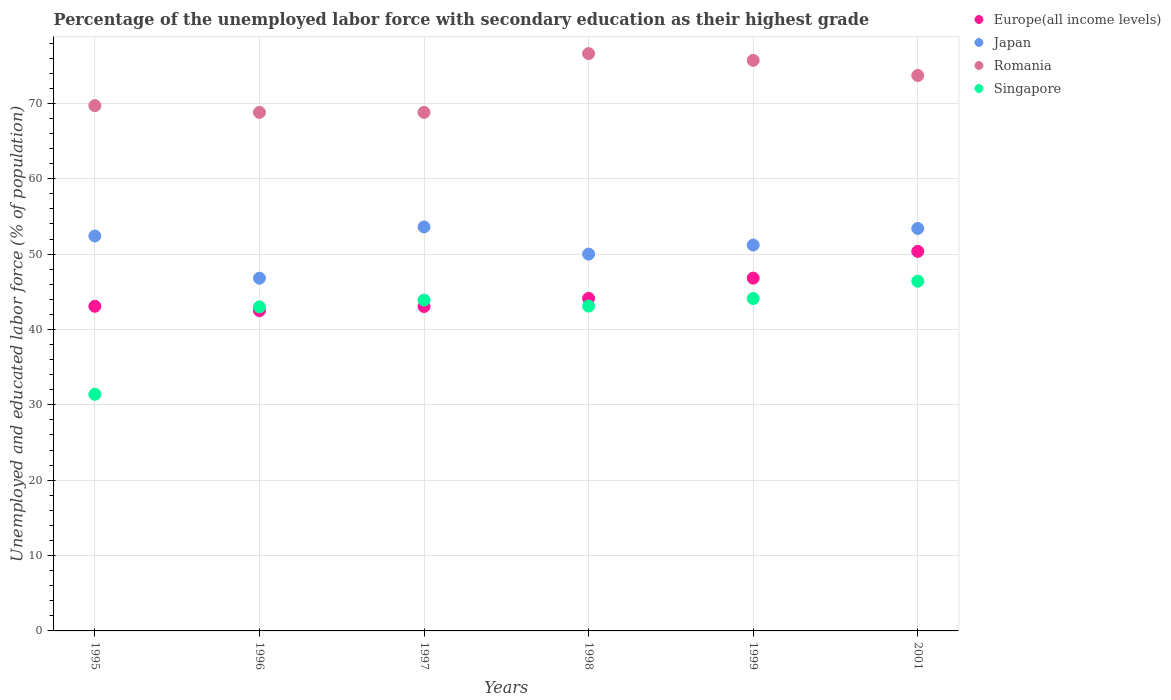What is the percentage of the unemployed labor force with secondary education in Japan in 2001?
Your answer should be very brief. 53.4. Across all years, what is the maximum percentage of the unemployed labor force with secondary education in Singapore?
Offer a terse response. 46.4. Across all years, what is the minimum percentage of the unemployed labor force with secondary education in Singapore?
Offer a very short reply. 31.4. In which year was the percentage of the unemployed labor force with secondary education in Europe(all income levels) minimum?
Your answer should be very brief. 1996. What is the total percentage of the unemployed labor force with secondary education in Romania in the graph?
Your answer should be very brief. 433.3. What is the difference between the percentage of the unemployed labor force with secondary education in Europe(all income levels) in 1995 and that in 1998?
Give a very brief answer. -1.05. What is the difference between the percentage of the unemployed labor force with secondary education in Europe(all income levels) in 1995 and the percentage of the unemployed labor force with secondary education in Romania in 1996?
Make the answer very short. -25.73. What is the average percentage of the unemployed labor force with secondary education in Romania per year?
Your answer should be very brief. 72.22. In the year 1997, what is the difference between the percentage of the unemployed labor force with secondary education in Japan and percentage of the unemployed labor force with secondary education in Romania?
Give a very brief answer. -15.2. What is the ratio of the percentage of the unemployed labor force with secondary education in Europe(all income levels) in 1996 to that in 2001?
Ensure brevity in your answer.  0.84. What is the difference between the highest and the second highest percentage of the unemployed labor force with secondary education in Europe(all income levels)?
Ensure brevity in your answer.  3.55. What is the difference between the highest and the lowest percentage of the unemployed labor force with secondary education in Europe(all income levels)?
Your answer should be very brief. 7.87. In how many years, is the percentage of the unemployed labor force with secondary education in Europe(all income levels) greater than the average percentage of the unemployed labor force with secondary education in Europe(all income levels) taken over all years?
Make the answer very short. 2. Is it the case that in every year, the sum of the percentage of the unemployed labor force with secondary education in Singapore and percentage of the unemployed labor force with secondary education in Europe(all income levels)  is greater than the sum of percentage of the unemployed labor force with secondary education in Japan and percentage of the unemployed labor force with secondary education in Romania?
Your answer should be compact. No. Is it the case that in every year, the sum of the percentage of the unemployed labor force with secondary education in Singapore and percentage of the unemployed labor force with secondary education in Romania  is greater than the percentage of the unemployed labor force with secondary education in Japan?
Offer a terse response. Yes. Is the percentage of the unemployed labor force with secondary education in Japan strictly greater than the percentage of the unemployed labor force with secondary education in Romania over the years?
Provide a succinct answer. No. How many years are there in the graph?
Offer a very short reply. 6. What is the difference between two consecutive major ticks on the Y-axis?
Ensure brevity in your answer.  10. How are the legend labels stacked?
Offer a very short reply. Vertical. What is the title of the graph?
Provide a succinct answer. Percentage of the unemployed labor force with secondary education as their highest grade. What is the label or title of the Y-axis?
Keep it short and to the point. Unemployed and educated labor force (% of population). What is the Unemployed and educated labor force (% of population) of Europe(all income levels) in 1995?
Make the answer very short. 43.07. What is the Unemployed and educated labor force (% of population) of Japan in 1995?
Make the answer very short. 52.4. What is the Unemployed and educated labor force (% of population) in Romania in 1995?
Ensure brevity in your answer.  69.7. What is the Unemployed and educated labor force (% of population) of Singapore in 1995?
Your answer should be very brief. 31.4. What is the Unemployed and educated labor force (% of population) of Europe(all income levels) in 1996?
Provide a short and direct response. 42.49. What is the Unemployed and educated labor force (% of population) of Japan in 1996?
Offer a very short reply. 46.8. What is the Unemployed and educated labor force (% of population) in Romania in 1996?
Give a very brief answer. 68.8. What is the Unemployed and educated labor force (% of population) in Europe(all income levels) in 1997?
Provide a short and direct response. 43.04. What is the Unemployed and educated labor force (% of population) in Japan in 1997?
Offer a terse response. 53.6. What is the Unemployed and educated labor force (% of population) of Romania in 1997?
Provide a short and direct response. 68.8. What is the Unemployed and educated labor force (% of population) of Singapore in 1997?
Ensure brevity in your answer.  43.9. What is the Unemployed and educated labor force (% of population) in Europe(all income levels) in 1998?
Your answer should be compact. 44.13. What is the Unemployed and educated labor force (% of population) of Japan in 1998?
Keep it short and to the point. 50. What is the Unemployed and educated labor force (% of population) of Romania in 1998?
Make the answer very short. 76.6. What is the Unemployed and educated labor force (% of population) of Singapore in 1998?
Provide a short and direct response. 43.1. What is the Unemployed and educated labor force (% of population) in Europe(all income levels) in 1999?
Give a very brief answer. 46.81. What is the Unemployed and educated labor force (% of population) in Japan in 1999?
Your response must be concise. 51.2. What is the Unemployed and educated labor force (% of population) in Romania in 1999?
Provide a succinct answer. 75.7. What is the Unemployed and educated labor force (% of population) of Singapore in 1999?
Your answer should be compact. 44.1. What is the Unemployed and educated labor force (% of population) of Europe(all income levels) in 2001?
Make the answer very short. 50.36. What is the Unemployed and educated labor force (% of population) of Japan in 2001?
Make the answer very short. 53.4. What is the Unemployed and educated labor force (% of population) in Romania in 2001?
Your response must be concise. 73.7. What is the Unemployed and educated labor force (% of population) in Singapore in 2001?
Ensure brevity in your answer.  46.4. Across all years, what is the maximum Unemployed and educated labor force (% of population) in Europe(all income levels)?
Your answer should be very brief. 50.36. Across all years, what is the maximum Unemployed and educated labor force (% of population) of Japan?
Your response must be concise. 53.6. Across all years, what is the maximum Unemployed and educated labor force (% of population) in Romania?
Your answer should be very brief. 76.6. Across all years, what is the maximum Unemployed and educated labor force (% of population) in Singapore?
Your answer should be compact. 46.4. Across all years, what is the minimum Unemployed and educated labor force (% of population) of Europe(all income levels)?
Make the answer very short. 42.49. Across all years, what is the minimum Unemployed and educated labor force (% of population) of Japan?
Your response must be concise. 46.8. Across all years, what is the minimum Unemployed and educated labor force (% of population) of Romania?
Your response must be concise. 68.8. Across all years, what is the minimum Unemployed and educated labor force (% of population) of Singapore?
Your answer should be very brief. 31.4. What is the total Unemployed and educated labor force (% of population) in Europe(all income levels) in the graph?
Ensure brevity in your answer.  269.91. What is the total Unemployed and educated labor force (% of population) in Japan in the graph?
Your response must be concise. 307.4. What is the total Unemployed and educated labor force (% of population) of Romania in the graph?
Your response must be concise. 433.3. What is the total Unemployed and educated labor force (% of population) in Singapore in the graph?
Offer a terse response. 251.9. What is the difference between the Unemployed and educated labor force (% of population) of Europe(all income levels) in 1995 and that in 1996?
Keep it short and to the point. 0.58. What is the difference between the Unemployed and educated labor force (% of population) in Singapore in 1995 and that in 1996?
Keep it short and to the point. -11.6. What is the difference between the Unemployed and educated labor force (% of population) of Europe(all income levels) in 1995 and that in 1997?
Provide a succinct answer. 0.03. What is the difference between the Unemployed and educated labor force (% of population) of Romania in 1995 and that in 1997?
Give a very brief answer. 0.9. What is the difference between the Unemployed and educated labor force (% of population) of Europe(all income levels) in 1995 and that in 1998?
Your answer should be compact. -1.05. What is the difference between the Unemployed and educated labor force (% of population) in Japan in 1995 and that in 1998?
Your answer should be very brief. 2.4. What is the difference between the Unemployed and educated labor force (% of population) in Romania in 1995 and that in 1998?
Your response must be concise. -6.9. What is the difference between the Unemployed and educated labor force (% of population) in Singapore in 1995 and that in 1998?
Offer a terse response. -11.7. What is the difference between the Unemployed and educated labor force (% of population) in Europe(all income levels) in 1995 and that in 1999?
Offer a terse response. -3.74. What is the difference between the Unemployed and educated labor force (% of population) in Japan in 1995 and that in 1999?
Your answer should be compact. 1.2. What is the difference between the Unemployed and educated labor force (% of population) in Romania in 1995 and that in 1999?
Ensure brevity in your answer.  -6. What is the difference between the Unemployed and educated labor force (% of population) of Europe(all income levels) in 1995 and that in 2001?
Offer a terse response. -7.29. What is the difference between the Unemployed and educated labor force (% of population) of Japan in 1995 and that in 2001?
Ensure brevity in your answer.  -1. What is the difference between the Unemployed and educated labor force (% of population) of Europe(all income levels) in 1996 and that in 1997?
Provide a succinct answer. -0.55. What is the difference between the Unemployed and educated labor force (% of population) of Japan in 1996 and that in 1997?
Ensure brevity in your answer.  -6.8. What is the difference between the Unemployed and educated labor force (% of population) in Romania in 1996 and that in 1997?
Give a very brief answer. 0. What is the difference between the Unemployed and educated labor force (% of population) in Europe(all income levels) in 1996 and that in 1998?
Your answer should be very brief. -1.64. What is the difference between the Unemployed and educated labor force (% of population) of Romania in 1996 and that in 1998?
Offer a terse response. -7.8. What is the difference between the Unemployed and educated labor force (% of population) in Europe(all income levels) in 1996 and that in 1999?
Provide a succinct answer. -4.32. What is the difference between the Unemployed and educated labor force (% of population) in Romania in 1996 and that in 1999?
Your response must be concise. -6.9. What is the difference between the Unemployed and educated labor force (% of population) in Singapore in 1996 and that in 1999?
Your response must be concise. -1.1. What is the difference between the Unemployed and educated labor force (% of population) in Europe(all income levels) in 1996 and that in 2001?
Make the answer very short. -7.87. What is the difference between the Unemployed and educated labor force (% of population) in Europe(all income levels) in 1997 and that in 1998?
Ensure brevity in your answer.  -1.08. What is the difference between the Unemployed and educated labor force (% of population) of Romania in 1997 and that in 1998?
Give a very brief answer. -7.8. What is the difference between the Unemployed and educated labor force (% of population) of Europe(all income levels) in 1997 and that in 1999?
Offer a very short reply. -3.76. What is the difference between the Unemployed and educated labor force (% of population) in Europe(all income levels) in 1997 and that in 2001?
Your response must be concise. -7.32. What is the difference between the Unemployed and educated labor force (% of population) of Singapore in 1997 and that in 2001?
Keep it short and to the point. -2.5. What is the difference between the Unemployed and educated labor force (% of population) in Europe(all income levels) in 1998 and that in 1999?
Make the answer very short. -2.68. What is the difference between the Unemployed and educated labor force (% of population) of Europe(all income levels) in 1998 and that in 2001?
Your answer should be compact. -6.23. What is the difference between the Unemployed and educated labor force (% of population) in Romania in 1998 and that in 2001?
Your answer should be very brief. 2.9. What is the difference between the Unemployed and educated labor force (% of population) of Europe(all income levels) in 1999 and that in 2001?
Your response must be concise. -3.55. What is the difference between the Unemployed and educated labor force (% of population) in Japan in 1999 and that in 2001?
Your answer should be very brief. -2.2. What is the difference between the Unemployed and educated labor force (% of population) of Romania in 1999 and that in 2001?
Offer a terse response. 2. What is the difference between the Unemployed and educated labor force (% of population) in Europe(all income levels) in 1995 and the Unemployed and educated labor force (% of population) in Japan in 1996?
Ensure brevity in your answer.  -3.73. What is the difference between the Unemployed and educated labor force (% of population) in Europe(all income levels) in 1995 and the Unemployed and educated labor force (% of population) in Romania in 1996?
Your response must be concise. -25.73. What is the difference between the Unemployed and educated labor force (% of population) in Europe(all income levels) in 1995 and the Unemployed and educated labor force (% of population) in Singapore in 1996?
Offer a terse response. 0.07. What is the difference between the Unemployed and educated labor force (% of population) in Japan in 1995 and the Unemployed and educated labor force (% of population) in Romania in 1996?
Your response must be concise. -16.4. What is the difference between the Unemployed and educated labor force (% of population) of Japan in 1995 and the Unemployed and educated labor force (% of population) of Singapore in 1996?
Your answer should be compact. 9.4. What is the difference between the Unemployed and educated labor force (% of population) in Romania in 1995 and the Unemployed and educated labor force (% of population) in Singapore in 1996?
Provide a succinct answer. 26.7. What is the difference between the Unemployed and educated labor force (% of population) in Europe(all income levels) in 1995 and the Unemployed and educated labor force (% of population) in Japan in 1997?
Keep it short and to the point. -10.53. What is the difference between the Unemployed and educated labor force (% of population) in Europe(all income levels) in 1995 and the Unemployed and educated labor force (% of population) in Romania in 1997?
Offer a terse response. -25.73. What is the difference between the Unemployed and educated labor force (% of population) of Europe(all income levels) in 1995 and the Unemployed and educated labor force (% of population) of Singapore in 1997?
Your response must be concise. -0.83. What is the difference between the Unemployed and educated labor force (% of population) of Japan in 1995 and the Unemployed and educated labor force (% of population) of Romania in 1997?
Ensure brevity in your answer.  -16.4. What is the difference between the Unemployed and educated labor force (% of population) of Japan in 1995 and the Unemployed and educated labor force (% of population) of Singapore in 1997?
Offer a very short reply. 8.5. What is the difference between the Unemployed and educated labor force (% of population) in Romania in 1995 and the Unemployed and educated labor force (% of population) in Singapore in 1997?
Keep it short and to the point. 25.8. What is the difference between the Unemployed and educated labor force (% of population) of Europe(all income levels) in 1995 and the Unemployed and educated labor force (% of population) of Japan in 1998?
Make the answer very short. -6.93. What is the difference between the Unemployed and educated labor force (% of population) in Europe(all income levels) in 1995 and the Unemployed and educated labor force (% of population) in Romania in 1998?
Provide a short and direct response. -33.53. What is the difference between the Unemployed and educated labor force (% of population) of Europe(all income levels) in 1995 and the Unemployed and educated labor force (% of population) of Singapore in 1998?
Your response must be concise. -0.03. What is the difference between the Unemployed and educated labor force (% of population) in Japan in 1995 and the Unemployed and educated labor force (% of population) in Romania in 1998?
Ensure brevity in your answer.  -24.2. What is the difference between the Unemployed and educated labor force (% of population) of Romania in 1995 and the Unemployed and educated labor force (% of population) of Singapore in 1998?
Offer a terse response. 26.6. What is the difference between the Unemployed and educated labor force (% of population) in Europe(all income levels) in 1995 and the Unemployed and educated labor force (% of population) in Japan in 1999?
Your answer should be very brief. -8.13. What is the difference between the Unemployed and educated labor force (% of population) in Europe(all income levels) in 1995 and the Unemployed and educated labor force (% of population) in Romania in 1999?
Keep it short and to the point. -32.63. What is the difference between the Unemployed and educated labor force (% of population) in Europe(all income levels) in 1995 and the Unemployed and educated labor force (% of population) in Singapore in 1999?
Offer a terse response. -1.03. What is the difference between the Unemployed and educated labor force (% of population) of Japan in 1995 and the Unemployed and educated labor force (% of population) of Romania in 1999?
Give a very brief answer. -23.3. What is the difference between the Unemployed and educated labor force (% of population) in Japan in 1995 and the Unemployed and educated labor force (% of population) in Singapore in 1999?
Provide a succinct answer. 8.3. What is the difference between the Unemployed and educated labor force (% of population) in Romania in 1995 and the Unemployed and educated labor force (% of population) in Singapore in 1999?
Offer a terse response. 25.6. What is the difference between the Unemployed and educated labor force (% of population) of Europe(all income levels) in 1995 and the Unemployed and educated labor force (% of population) of Japan in 2001?
Offer a terse response. -10.33. What is the difference between the Unemployed and educated labor force (% of population) in Europe(all income levels) in 1995 and the Unemployed and educated labor force (% of population) in Romania in 2001?
Your answer should be compact. -30.63. What is the difference between the Unemployed and educated labor force (% of population) of Europe(all income levels) in 1995 and the Unemployed and educated labor force (% of population) of Singapore in 2001?
Keep it short and to the point. -3.33. What is the difference between the Unemployed and educated labor force (% of population) of Japan in 1995 and the Unemployed and educated labor force (% of population) of Romania in 2001?
Provide a short and direct response. -21.3. What is the difference between the Unemployed and educated labor force (% of population) in Japan in 1995 and the Unemployed and educated labor force (% of population) in Singapore in 2001?
Provide a short and direct response. 6. What is the difference between the Unemployed and educated labor force (% of population) in Romania in 1995 and the Unemployed and educated labor force (% of population) in Singapore in 2001?
Your response must be concise. 23.3. What is the difference between the Unemployed and educated labor force (% of population) of Europe(all income levels) in 1996 and the Unemployed and educated labor force (% of population) of Japan in 1997?
Your answer should be compact. -11.11. What is the difference between the Unemployed and educated labor force (% of population) of Europe(all income levels) in 1996 and the Unemployed and educated labor force (% of population) of Romania in 1997?
Your response must be concise. -26.31. What is the difference between the Unemployed and educated labor force (% of population) of Europe(all income levels) in 1996 and the Unemployed and educated labor force (% of population) of Singapore in 1997?
Make the answer very short. -1.41. What is the difference between the Unemployed and educated labor force (% of population) in Japan in 1996 and the Unemployed and educated labor force (% of population) in Romania in 1997?
Your response must be concise. -22. What is the difference between the Unemployed and educated labor force (% of population) in Romania in 1996 and the Unemployed and educated labor force (% of population) in Singapore in 1997?
Your answer should be compact. 24.9. What is the difference between the Unemployed and educated labor force (% of population) of Europe(all income levels) in 1996 and the Unemployed and educated labor force (% of population) of Japan in 1998?
Your answer should be very brief. -7.51. What is the difference between the Unemployed and educated labor force (% of population) of Europe(all income levels) in 1996 and the Unemployed and educated labor force (% of population) of Romania in 1998?
Keep it short and to the point. -34.11. What is the difference between the Unemployed and educated labor force (% of population) in Europe(all income levels) in 1996 and the Unemployed and educated labor force (% of population) in Singapore in 1998?
Make the answer very short. -0.61. What is the difference between the Unemployed and educated labor force (% of population) of Japan in 1996 and the Unemployed and educated labor force (% of population) of Romania in 1998?
Your answer should be very brief. -29.8. What is the difference between the Unemployed and educated labor force (% of population) of Japan in 1996 and the Unemployed and educated labor force (% of population) of Singapore in 1998?
Keep it short and to the point. 3.7. What is the difference between the Unemployed and educated labor force (% of population) in Romania in 1996 and the Unemployed and educated labor force (% of population) in Singapore in 1998?
Give a very brief answer. 25.7. What is the difference between the Unemployed and educated labor force (% of population) of Europe(all income levels) in 1996 and the Unemployed and educated labor force (% of population) of Japan in 1999?
Provide a succinct answer. -8.71. What is the difference between the Unemployed and educated labor force (% of population) of Europe(all income levels) in 1996 and the Unemployed and educated labor force (% of population) of Romania in 1999?
Your response must be concise. -33.21. What is the difference between the Unemployed and educated labor force (% of population) of Europe(all income levels) in 1996 and the Unemployed and educated labor force (% of population) of Singapore in 1999?
Your response must be concise. -1.61. What is the difference between the Unemployed and educated labor force (% of population) in Japan in 1996 and the Unemployed and educated labor force (% of population) in Romania in 1999?
Your answer should be very brief. -28.9. What is the difference between the Unemployed and educated labor force (% of population) of Japan in 1996 and the Unemployed and educated labor force (% of population) of Singapore in 1999?
Provide a short and direct response. 2.7. What is the difference between the Unemployed and educated labor force (% of population) of Romania in 1996 and the Unemployed and educated labor force (% of population) of Singapore in 1999?
Offer a very short reply. 24.7. What is the difference between the Unemployed and educated labor force (% of population) in Europe(all income levels) in 1996 and the Unemployed and educated labor force (% of population) in Japan in 2001?
Your answer should be very brief. -10.91. What is the difference between the Unemployed and educated labor force (% of population) of Europe(all income levels) in 1996 and the Unemployed and educated labor force (% of population) of Romania in 2001?
Your answer should be very brief. -31.21. What is the difference between the Unemployed and educated labor force (% of population) in Europe(all income levels) in 1996 and the Unemployed and educated labor force (% of population) in Singapore in 2001?
Offer a very short reply. -3.91. What is the difference between the Unemployed and educated labor force (% of population) of Japan in 1996 and the Unemployed and educated labor force (% of population) of Romania in 2001?
Your response must be concise. -26.9. What is the difference between the Unemployed and educated labor force (% of population) in Japan in 1996 and the Unemployed and educated labor force (% of population) in Singapore in 2001?
Offer a very short reply. 0.4. What is the difference between the Unemployed and educated labor force (% of population) of Romania in 1996 and the Unemployed and educated labor force (% of population) of Singapore in 2001?
Keep it short and to the point. 22.4. What is the difference between the Unemployed and educated labor force (% of population) in Europe(all income levels) in 1997 and the Unemployed and educated labor force (% of population) in Japan in 1998?
Your response must be concise. -6.96. What is the difference between the Unemployed and educated labor force (% of population) of Europe(all income levels) in 1997 and the Unemployed and educated labor force (% of population) of Romania in 1998?
Your response must be concise. -33.56. What is the difference between the Unemployed and educated labor force (% of population) in Europe(all income levels) in 1997 and the Unemployed and educated labor force (% of population) in Singapore in 1998?
Keep it short and to the point. -0.06. What is the difference between the Unemployed and educated labor force (% of population) in Japan in 1997 and the Unemployed and educated labor force (% of population) in Singapore in 1998?
Offer a terse response. 10.5. What is the difference between the Unemployed and educated labor force (% of population) in Romania in 1997 and the Unemployed and educated labor force (% of population) in Singapore in 1998?
Offer a terse response. 25.7. What is the difference between the Unemployed and educated labor force (% of population) of Europe(all income levels) in 1997 and the Unemployed and educated labor force (% of population) of Japan in 1999?
Ensure brevity in your answer.  -8.16. What is the difference between the Unemployed and educated labor force (% of population) of Europe(all income levels) in 1997 and the Unemployed and educated labor force (% of population) of Romania in 1999?
Offer a very short reply. -32.66. What is the difference between the Unemployed and educated labor force (% of population) of Europe(all income levels) in 1997 and the Unemployed and educated labor force (% of population) of Singapore in 1999?
Provide a short and direct response. -1.06. What is the difference between the Unemployed and educated labor force (% of population) of Japan in 1997 and the Unemployed and educated labor force (% of population) of Romania in 1999?
Offer a very short reply. -22.1. What is the difference between the Unemployed and educated labor force (% of population) in Japan in 1997 and the Unemployed and educated labor force (% of population) in Singapore in 1999?
Your response must be concise. 9.5. What is the difference between the Unemployed and educated labor force (% of population) of Romania in 1997 and the Unemployed and educated labor force (% of population) of Singapore in 1999?
Your answer should be very brief. 24.7. What is the difference between the Unemployed and educated labor force (% of population) in Europe(all income levels) in 1997 and the Unemployed and educated labor force (% of population) in Japan in 2001?
Your answer should be compact. -10.36. What is the difference between the Unemployed and educated labor force (% of population) in Europe(all income levels) in 1997 and the Unemployed and educated labor force (% of population) in Romania in 2001?
Provide a short and direct response. -30.66. What is the difference between the Unemployed and educated labor force (% of population) in Europe(all income levels) in 1997 and the Unemployed and educated labor force (% of population) in Singapore in 2001?
Your answer should be compact. -3.36. What is the difference between the Unemployed and educated labor force (% of population) in Japan in 1997 and the Unemployed and educated labor force (% of population) in Romania in 2001?
Your response must be concise. -20.1. What is the difference between the Unemployed and educated labor force (% of population) of Romania in 1997 and the Unemployed and educated labor force (% of population) of Singapore in 2001?
Provide a succinct answer. 22.4. What is the difference between the Unemployed and educated labor force (% of population) in Europe(all income levels) in 1998 and the Unemployed and educated labor force (% of population) in Japan in 1999?
Offer a terse response. -7.07. What is the difference between the Unemployed and educated labor force (% of population) of Europe(all income levels) in 1998 and the Unemployed and educated labor force (% of population) of Romania in 1999?
Give a very brief answer. -31.57. What is the difference between the Unemployed and educated labor force (% of population) of Europe(all income levels) in 1998 and the Unemployed and educated labor force (% of population) of Singapore in 1999?
Your answer should be very brief. 0.03. What is the difference between the Unemployed and educated labor force (% of population) in Japan in 1998 and the Unemployed and educated labor force (% of population) in Romania in 1999?
Your answer should be very brief. -25.7. What is the difference between the Unemployed and educated labor force (% of population) of Japan in 1998 and the Unemployed and educated labor force (% of population) of Singapore in 1999?
Provide a succinct answer. 5.9. What is the difference between the Unemployed and educated labor force (% of population) of Romania in 1998 and the Unemployed and educated labor force (% of population) of Singapore in 1999?
Provide a succinct answer. 32.5. What is the difference between the Unemployed and educated labor force (% of population) of Europe(all income levels) in 1998 and the Unemployed and educated labor force (% of population) of Japan in 2001?
Provide a succinct answer. -9.27. What is the difference between the Unemployed and educated labor force (% of population) in Europe(all income levels) in 1998 and the Unemployed and educated labor force (% of population) in Romania in 2001?
Keep it short and to the point. -29.57. What is the difference between the Unemployed and educated labor force (% of population) of Europe(all income levels) in 1998 and the Unemployed and educated labor force (% of population) of Singapore in 2001?
Your answer should be very brief. -2.27. What is the difference between the Unemployed and educated labor force (% of population) in Japan in 1998 and the Unemployed and educated labor force (% of population) in Romania in 2001?
Give a very brief answer. -23.7. What is the difference between the Unemployed and educated labor force (% of population) of Romania in 1998 and the Unemployed and educated labor force (% of population) of Singapore in 2001?
Your response must be concise. 30.2. What is the difference between the Unemployed and educated labor force (% of population) in Europe(all income levels) in 1999 and the Unemployed and educated labor force (% of population) in Japan in 2001?
Your response must be concise. -6.59. What is the difference between the Unemployed and educated labor force (% of population) in Europe(all income levels) in 1999 and the Unemployed and educated labor force (% of population) in Romania in 2001?
Provide a short and direct response. -26.89. What is the difference between the Unemployed and educated labor force (% of population) in Europe(all income levels) in 1999 and the Unemployed and educated labor force (% of population) in Singapore in 2001?
Offer a very short reply. 0.41. What is the difference between the Unemployed and educated labor force (% of population) in Japan in 1999 and the Unemployed and educated labor force (% of population) in Romania in 2001?
Offer a terse response. -22.5. What is the difference between the Unemployed and educated labor force (% of population) of Romania in 1999 and the Unemployed and educated labor force (% of population) of Singapore in 2001?
Provide a succinct answer. 29.3. What is the average Unemployed and educated labor force (% of population) of Europe(all income levels) per year?
Make the answer very short. 44.98. What is the average Unemployed and educated labor force (% of population) in Japan per year?
Your response must be concise. 51.23. What is the average Unemployed and educated labor force (% of population) of Romania per year?
Offer a terse response. 72.22. What is the average Unemployed and educated labor force (% of population) of Singapore per year?
Your answer should be compact. 41.98. In the year 1995, what is the difference between the Unemployed and educated labor force (% of population) in Europe(all income levels) and Unemployed and educated labor force (% of population) in Japan?
Your answer should be compact. -9.33. In the year 1995, what is the difference between the Unemployed and educated labor force (% of population) of Europe(all income levels) and Unemployed and educated labor force (% of population) of Romania?
Provide a short and direct response. -26.63. In the year 1995, what is the difference between the Unemployed and educated labor force (% of population) of Europe(all income levels) and Unemployed and educated labor force (% of population) of Singapore?
Keep it short and to the point. 11.67. In the year 1995, what is the difference between the Unemployed and educated labor force (% of population) of Japan and Unemployed and educated labor force (% of population) of Romania?
Make the answer very short. -17.3. In the year 1995, what is the difference between the Unemployed and educated labor force (% of population) in Japan and Unemployed and educated labor force (% of population) in Singapore?
Keep it short and to the point. 21. In the year 1995, what is the difference between the Unemployed and educated labor force (% of population) of Romania and Unemployed and educated labor force (% of population) of Singapore?
Your answer should be very brief. 38.3. In the year 1996, what is the difference between the Unemployed and educated labor force (% of population) in Europe(all income levels) and Unemployed and educated labor force (% of population) in Japan?
Make the answer very short. -4.31. In the year 1996, what is the difference between the Unemployed and educated labor force (% of population) of Europe(all income levels) and Unemployed and educated labor force (% of population) of Romania?
Keep it short and to the point. -26.31. In the year 1996, what is the difference between the Unemployed and educated labor force (% of population) in Europe(all income levels) and Unemployed and educated labor force (% of population) in Singapore?
Provide a succinct answer. -0.51. In the year 1996, what is the difference between the Unemployed and educated labor force (% of population) in Japan and Unemployed and educated labor force (% of population) in Romania?
Offer a terse response. -22. In the year 1996, what is the difference between the Unemployed and educated labor force (% of population) of Japan and Unemployed and educated labor force (% of population) of Singapore?
Offer a very short reply. 3.8. In the year 1996, what is the difference between the Unemployed and educated labor force (% of population) of Romania and Unemployed and educated labor force (% of population) of Singapore?
Your answer should be compact. 25.8. In the year 1997, what is the difference between the Unemployed and educated labor force (% of population) in Europe(all income levels) and Unemployed and educated labor force (% of population) in Japan?
Give a very brief answer. -10.56. In the year 1997, what is the difference between the Unemployed and educated labor force (% of population) of Europe(all income levels) and Unemployed and educated labor force (% of population) of Romania?
Make the answer very short. -25.76. In the year 1997, what is the difference between the Unemployed and educated labor force (% of population) of Europe(all income levels) and Unemployed and educated labor force (% of population) of Singapore?
Provide a succinct answer. -0.86. In the year 1997, what is the difference between the Unemployed and educated labor force (% of population) of Japan and Unemployed and educated labor force (% of population) of Romania?
Offer a terse response. -15.2. In the year 1997, what is the difference between the Unemployed and educated labor force (% of population) of Romania and Unemployed and educated labor force (% of population) of Singapore?
Ensure brevity in your answer.  24.9. In the year 1998, what is the difference between the Unemployed and educated labor force (% of population) of Europe(all income levels) and Unemployed and educated labor force (% of population) of Japan?
Offer a very short reply. -5.87. In the year 1998, what is the difference between the Unemployed and educated labor force (% of population) in Europe(all income levels) and Unemployed and educated labor force (% of population) in Romania?
Your answer should be compact. -32.47. In the year 1998, what is the difference between the Unemployed and educated labor force (% of population) in Europe(all income levels) and Unemployed and educated labor force (% of population) in Singapore?
Provide a short and direct response. 1.03. In the year 1998, what is the difference between the Unemployed and educated labor force (% of population) of Japan and Unemployed and educated labor force (% of population) of Romania?
Your answer should be very brief. -26.6. In the year 1998, what is the difference between the Unemployed and educated labor force (% of population) of Japan and Unemployed and educated labor force (% of population) of Singapore?
Keep it short and to the point. 6.9. In the year 1998, what is the difference between the Unemployed and educated labor force (% of population) of Romania and Unemployed and educated labor force (% of population) of Singapore?
Make the answer very short. 33.5. In the year 1999, what is the difference between the Unemployed and educated labor force (% of population) of Europe(all income levels) and Unemployed and educated labor force (% of population) of Japan?
Your response must be concise. -4.39. In the year 1999, what is the difference between the Unemployed and educated labor force (% of population) of Europe(all income levels) and Unemployed and educated labor force (% of population) of Romania?
Ensure brevity in your answer.  -28.89. In the year 1999, what is the difference between the Unemployed and educated labor force (% of population) in Europe(all income levels) and Unemployed and educated labor force (% of population) in Singapore?
Keep it short and to the point. 2.71. In the year 1999, what is the difference between the Unemployed and educated labor force (% of population) in Japan and Unemployed and educated labor force (% of population) in Romania?
Provide a succinct answer. -24.5. In the year 1999, what is the difference between the Unemployed and educated labor force (% of population) in Romania and Unemployed and educated labor force (% of population) in Singapore?
Your response must be concise. 31.6. In the year 2001, what is the difference between the Unemployed and educated labor force (% of population) of Europe(all income levels) and Unemployed and educated labor force (% of population) of Japan?
Your answer should be very brief. -3.04. In the year 2001, what is the difference between the Unemployed and educated labor force (% of population) in Europe(all income levels) and Unemployed and educated labor force (% of population) in Romania?
Give a very brief answer. -23.34. In the year 2001, what is the difference between the Unemployed and educated labor force (% of population) in Europe(all income levels) and Unemployed and educated labor force (% of population) in Singapore?
Your response must be concise. 3.96. In the year 2001, what is the difference between the Unemployed and educated labor force (% of population) in Japan and Unemployed and educated labor force (% of population) in Romania?
Offer a very short reply. -20.3. In the year 2001, what is the difference between the Unemployed and educated labor force (% of population) in Romania and Unemployed and educated labor force (% of population) in Singapore?
Provide a short and direct response. 27.3. What is the ratio of the Unemployed and educated labor force (% of population) in Europe(all income levels) in 1995 to that in 1996?
Provide a short and direct response. 1.01. What is the ratio of the Unemployed and educated labor force (% of population) of Japan in 1995 to that in 1996?
Give a very brief answer. 1.12. What is the ratio of the Unemployed and educated labor force (% of population) of Romania in 1995 to that in 1996?
Offer a very short reply. 1.01. What is the ratio of the Unemployed and educated labor force (% of population) in Singapore in 1995 to that in 1996?
Your answer should be compact. 0.73. What is the ratio of the Unemployed and educated labor force (% of population) in Japan in 1995 to that in 1997?
Ensure brevity in your answer.  0.98. What is the ratio of the Unemployed and educated labor force (% of population) of Romania in 1995 to that in 1997?
Your answer should be compact. 1.01. What is the ratio of the Unemployed and educated labor force (% of population) of Singapore in 1995 to that in 1997?
Provide a short and direct response. 0.72. What is the ratio of the Unemployed and educated labor force (% of population) of Europe(all income levels) in 1995 to that in 1998?
Your answer should be very brief. 0.98. What is the ratio of the Unemployed and educated labor force (% of population) in Japan in 1995 to that in 1998?
Offer a terse response. 1.05. What is the ratio of the Unemployed and educated labor force (% of population) in Romania in 1995 to that in 1998?
Keep it short and to the point. 0.91. What is the ratio of the Unemployed and educated labor force (% of population) of Singapore in 1995 to that in 1998?
Offer a terse response. 0.73. What is the ratio of the Unemployed and educated labor force (% of population) in Europe(all income levels) in 1995 to that in 1999?
Offer a very short reply. 0.92. What is the ratio of the Unemployed and educated labor force (% of population) in Japan in 1995 to that in 1999?
Your answer should be compact. 1.02. What is the ratio of the Unemployed and educated labor force (% of population) in Romania in 1995 to that in 1999?
Your answer should be very brief. 0.92. What is the ratio of the Unemployed and educated labor force (% of population) in Singapore in 1995 to that in 1999?
Ensure brevity in your answer.  0.71. What is the ratio of the Unemployed and educated labor force (% of population) of Europe(all income levels) in 1995 to that in 2001?
Give a very brief answer. 0.86. What is the ratio of the Unemployed and educated labor force (% of population) in Japan in 1995 to that in 2001?
Make the answer very short. 0.98. What is the ratio of the Unemployed and educated labor force (% of population) in Romania in 1995 to that in 2001?
Your answer should be compact. 0.95. What is the ratio of the Unemployed and educated labor force (% of population) of Singapore in 1995 to that in 2001?
Ensure brevity in your answer.  0.68. What is the ratio of the Unemployed and educated labor force (% of population) of Europe(all income levels) in 1996 to that in 1997?
Offer a terse response. 0.99. What is the ratio of the Unemployed and educated labor force (% of population) in Japan in 1996 to that in 1997?
Your response must be concise. 0.87. What is the ratio of the Unemployed and educated labor force (% of population) in Romania in 1996 to that in 1997?
Your answer should be very brief. 1. What is the ratio of the Unemployed and educated labor force (% of population) of Singapore in 1996 to that in 1997?
Make the answer very short. 0.98. What is the ratio of the Unemployed and educated labor force (% of population) of Europe(all income levels) in 1996 to that in 1998?
Keep it short and to the point. 0.96. What is the ratio of the Unemployed and educated labor force (% of population) of Japan in 1996 to that in 1998?
Provide a short and direct response. 0.94. What is the ratio of the Unemployed and educated labor force (% of population) in Romania in 1996 to that in 1998?
Your answer should be compact. 0.9. What is the ratio of the Unemployed and educated labor force (% of population) in Europe(all income levels) in 1996 to that in 1999?
Give a very brief answer. 0.91. What is the ratio of the Unemployed and educated labor force (% of population) in Japan in 1996 to that in 1999?
Offer a terse response. 0.91. What is the ratio of the Unemployed and educated labor force (% of population) of Romania in 1996 to that in 1999?
Provide a short and direct response. 0.91. What is the ratio of the Unemployed and educated labor force (% of population) of Singapore in 1996 to that in 1999?
Provide a succinct answer. 0.98. What is the ratio of the Unemployed and educated labor force (% of population) of Europe(all income levels) in 1996 to that in 2001?
Your answer should be very brief. 0.84. What is the ratio of the Unemployed and educated labor force (% of population) in Japan in 1996 to that in 2001?
Your response must be concise. 0.88. What is the ratio of the Unemployed and educated labor force (% of population) in Romania in 1996 to that in 2001?
Make the answer very short. 0.93. What is the ratio of the Unemployed and educated labor force (% of population) of Singapore in 1996 to that in 2001?
Your answer should be compact. 0.93. What is the ratio of the Unemployed and educated labor force (% of population) in Europe(all income levels) in 1997 to that in 1998?
Make the answer very short. 0.98. What is the ratio of the Unemployed and educated labor force (% of population) in Japan in 1997 to that in 1998?
Keep it short and to the point. 1.07. What is the ratio of the Unemployed and educated labor force (% of population) in Romania in 1997 to that in 1998?
Provide a short and direct response. 0.9. What is the ratio of the Unemployed and educated labor force (% of population) of Singapore in 1997 to that in 1998?
Provide a short and direct response. 1.02. What is the ratio of the Unemployed and educated labor force (% of population) of Europe(all income levels) in 1997 to that in 1999?
Offer a terse response. 0.92. What is the ratio of the Unemployed and educated labor force (% of population) of Japan in 1997 to that in 1999?
Provide a short and direct response. 1.05. What is the ratio of the Unemployed and educated labor force (% of population) in Romania in 1997 to that in 1999?
Keep it short and to the point. 0.91. What is the ratio of the Unemployed and educated labor force (% of population) of Singapore in 1997 to that in 1999?
Offer a very short reply. 1. What is the ratio of the Unemployed and educated labor force (% of population) of Europe(all income levels) in 1997 to that in 2001?
Your answer should be compact. 0.85. What is the ratio of the Unemployed and educated labor force (% of population) of Romania in 1997 to that in 2001?
Keep it short and to the point. 0.93. What is the ratio of the Unemployed and educated labor force (% of population) in Singapore in 1997 to that in 2001?
Ensure brevity in your answer.  0.95. What is the ratio of the Unemployed and educated labor force (% of population) in Europe(all income levels) in 1998 to that in 1999?
Your response must be concise. 0.94. What is the ratio of the Unemployed and educated labor force (% of population) in Japan in 1998 to that in 1999?
Offer a very short reply. 0.98. What is the ratio of the Unemployed and educated labor force (% of population) of Romania in 1998 to that in 1999?
Make the answer very short. 1.01. What is the ratio of the Unemployed and educated labor force (% of population) of Singapore in 1998 to that in 1999?
Offer a terse response. 0.98. What is the ratio of the Unemployed and educated labor force (% of population) of Europe(all income levels) in 1998 to that in 2001?
Your response must be concise. 0.88. What is the ratio of the Unemployed and educated labor force (% of population) in Japan in 1998 to that in 2001?
Your answer should be very brief. 0.94. What is the ratio of the Unemployed and educated labor force (% of population) of Romania in 1998 to that in 2001?
Give a very brief answer. 1.04. What is the ratio of the Unemployed and educated labor force (% of population) in Singapore in 1998 to that in 2001?
Keep it short and to the point. 0.93. What is the ratio of the Unemployed and educated labor force (% of population) of Europe(all income levels) in 1999 to that in 2001?
Ensure brevity in your answer.  0.93. What is the ratio of the Unemployed and educated labor force (% of population) in Japan in 1999 to that in 2001?
Make the answer very short. 0.96. What is the ratio of the Unemployed and educated labor force (% of population) of Romania in 1999 to that in 2001?
Ensure brevity in your answer.  1.03. What is the ratio of the Unemployed and educated labor force (% of population) of Singapore in 1999 to that in 2001?
Provide a succinct answer. 0.95. What is the difference between the highest and the second highest Unemployed and educated labor force (% of population) of Europe(all income levels)?
Offer a terse response. 3.55. What is the difference between the highest and the second highest Unemployed and educated labor force (% of population) in Japan?
Provide a succinct answer. 0.2. What is the difference between the highest and the lowest Unemployed and educated labor force (% of population) of Europe(all income levels)?
Give a very brief answer. 7.87. What is the difference between the highest and the lowest Unemployed and educated labor force (% of population) in Romania?
Offer a terse response. 7.8. 